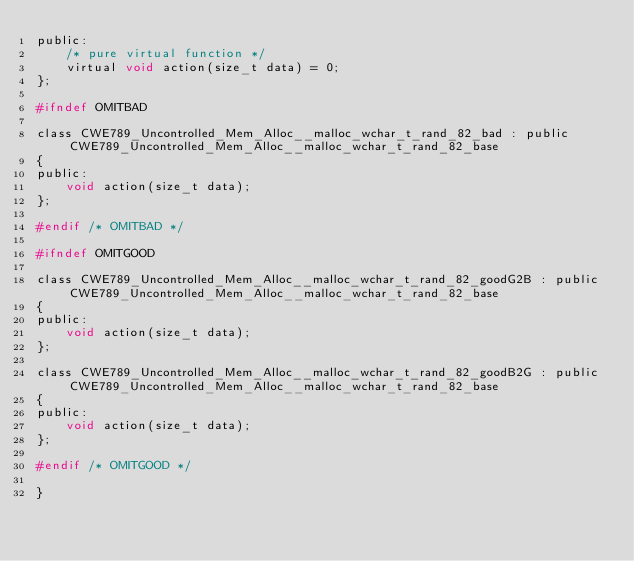<code> <loc_0><loc_0><loc_500><loc_500><_C_>public:
    /* pure virtual function */
    virtual void action(size_t data) = 0;
};

#ifndef OMITBAD

class CWE789_Uncontrolled_Mem_Alloc__malloc_wchar_t_rand_82_bad : public CWE789_Uncontrolled_Mem_Alloc__malloc_wchar_t_rand_82_base
{
public:
    void action(size_t data);
};

#endif /* OMITBAD */

#ifndef OMITGOOD

class CWE789_Uncontrolled_Mem_Alloc__malloc_wchar_t_rand_82_goodG2B : public CWE789_Uncontrolled_Mem_Alloc__malloc_wchar_t_rand_82_base
{
public:
    void action(size_t data);
};

class CWE789_Uncontrolled_Mem_Alloc__malloc_wchar_t_rand_82_goodB2G : public CWE789_Uncontrolled_Mem_Alloc__malloc_wchar_t_rand_82_base
{
public:
    void action(size_t data);
};

#endif /* OMITGOOD */

}
</code> 